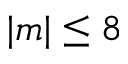<formula> <loc_0><loc_0><loc_500><loc_500>| m | \leq 8</formula> 